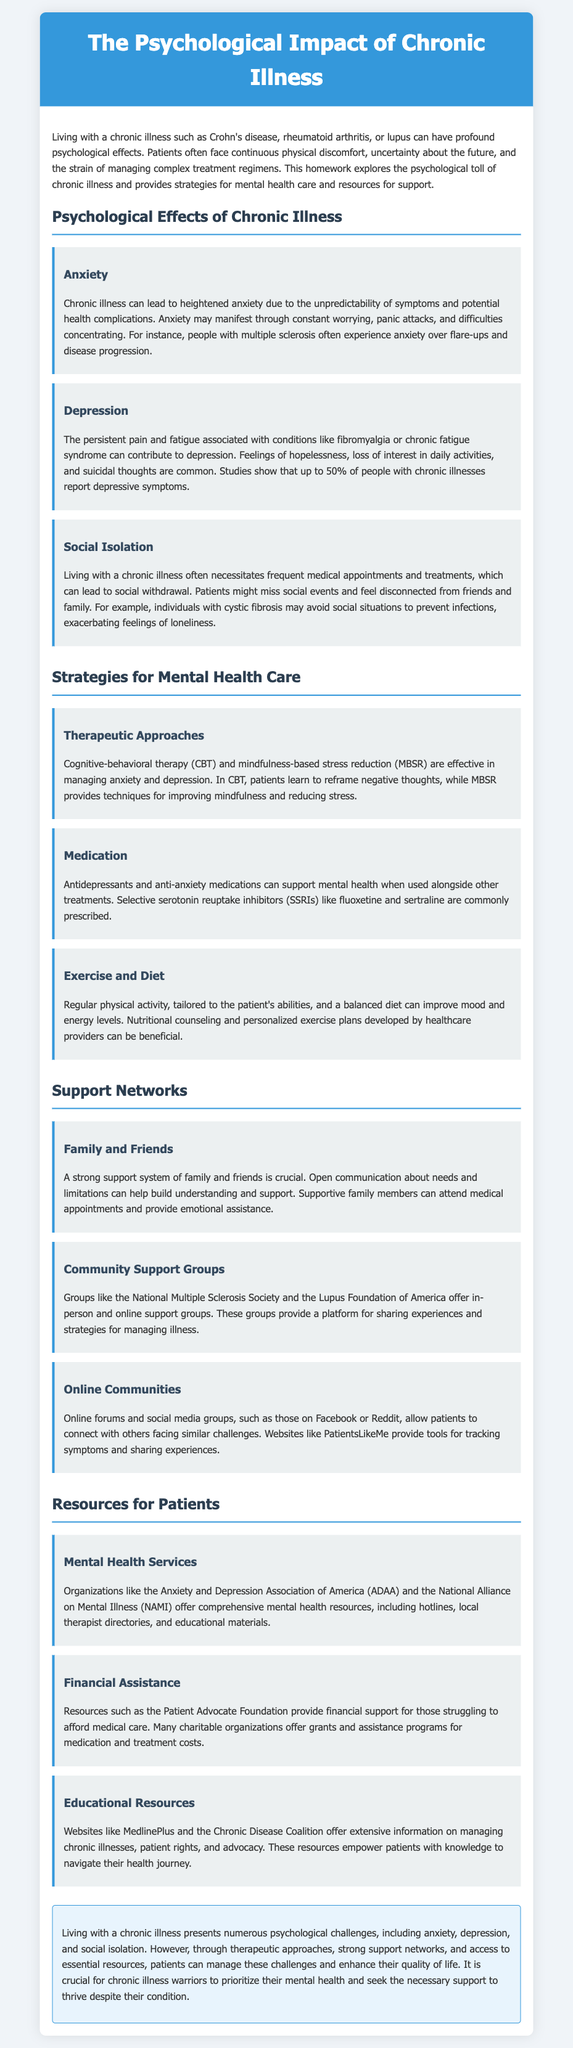What are some common psychological effects of chronic illness? The document lists anxiety, depression, and social isolation as common psychological effects of chronic illness.
Answer: anxiety, depression, social isolation What therapeutic approach is effective in managing anxiety? The document states that cognitive-behavioral therapy (CBT) is effective in managing anxiety.
Answer: cognitive-behavioral therapy What percentage of people with chronic illnesses report depressive symptoms? The document mentions that up to 50% of people with chronic illnesses report depressive symptoms.
Answer: 50% Name a resource organization for financial assistance. The document cites the Patient Advocate Foundation as a resource for financial assistance.
Answer: Patient Advocate Foundation How does chronic illness lead to social isolation? The document explains that chronic illness may necessitate frequent medical appointments and treatments, leading to social withdrawal.
Answer: frequent medical appointments and treatments What type of medication can support mental health? Antidepressants are mentioned as a type of medication that can support mental health.
Answer: Antidepressants What is one example of an online community mentioned in the document? The document lists Facebook and Reddit as examples of online communities for patients.
Answer: Facebook, Reddit What is a crucial aspect of a strong support system? Open communication about needs and limitations is mentioned as crucial for a strong support system.
Answer: Open communication Which organization offers hotlines and local therapist directories? The document states that the Anxiety and Depression Association of America (ADAA) offers hotlines and local therapist directories.
Answer: Anxiety and Depression Association of America 